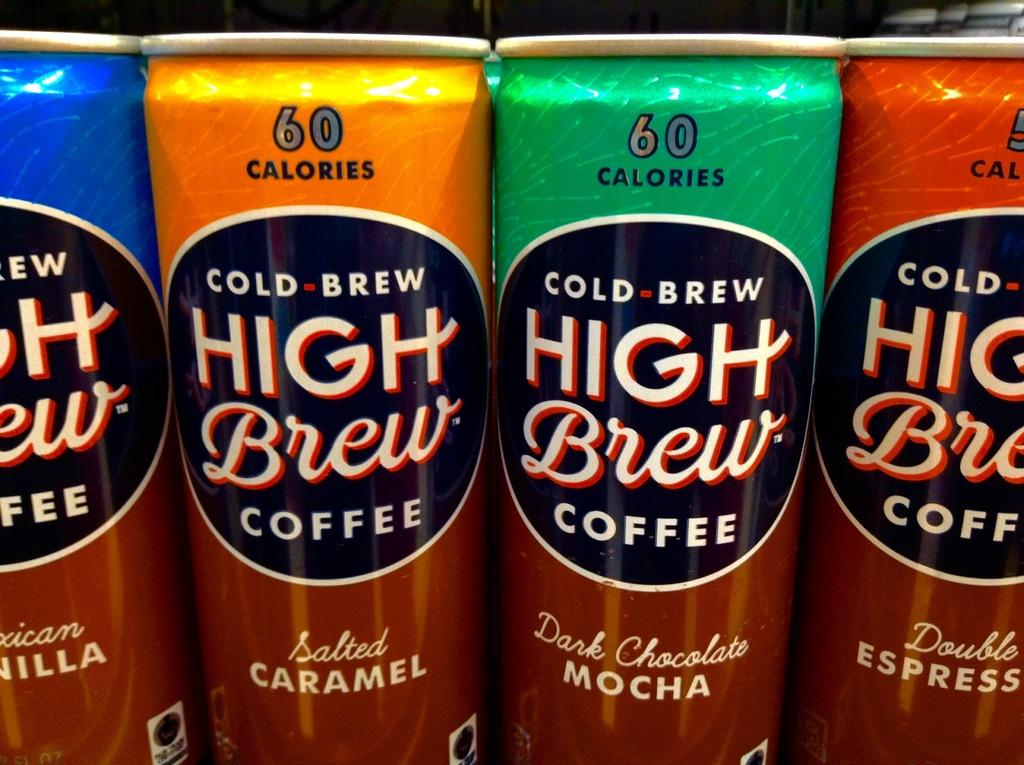<image>
Relay a brief, clear account of the picture shown. Several cans of coffee which say that are high brew and come in different flavours. 